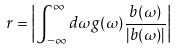Convert formula to latex. <formula><loc_0><loc_0><loc_500><loc_500>r = \left | \int _ { - \infty } ^ { \infty } d \omega g ( \omega ) \frac { b ( \omega ) } { | b ( \omega ) | } \right |</formula> 